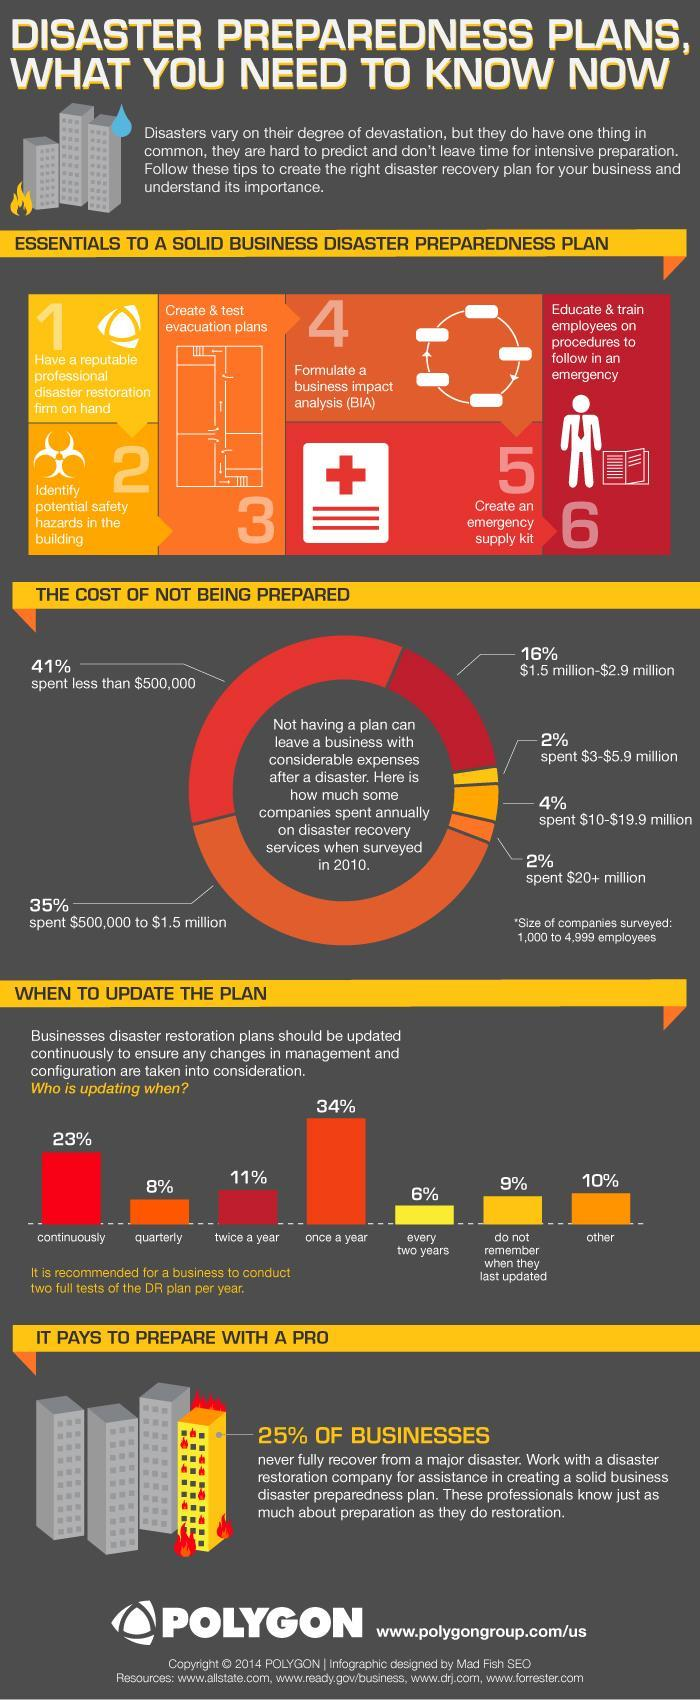In which step of creating a disaster preparedness plan is a business impact analysis formulated?
Answer the question with a short phrase. 4 What is total percentage of companies that had to spend $1.5 million or above on disaster recovery? 24% What percent of companies update their disaster restoration plans every two years? 6% What percent of companies spent less than half a million dollars on disaster recovery? 41% What is step 5 in creating a disaster preparedness plan? Create an emergency supply kit In which step of creating disaster preparedness plan are potential safety hazards identified? 2 How many of the companies update their disaster restoration plans continuously? 23% What is step 6 in creating a disaster preparedness plan? educate & train employees on procedures to follow in an emergency What is step 3 in creating a disaster preparedness plan? Create and test evacuation plans What is step 1 in creating a disaster preparedness plan? have a reputable professional restoration firm on hand 